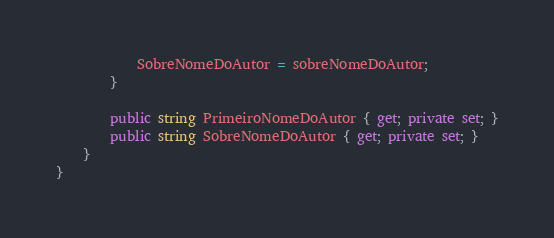Convert code to text. <code><loc_0><loc_0><loc_500><loc_500><_C#_>            SobreNomeDoAutor = sobreNomeDoAutor;
        }

        public string PrimeiroNomeDoAutor { get; private set; }
        public string SobreNomeDoAutor { get; private set; }
    }
}</code> 